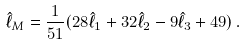Convert formula to latex. <formula><loc_0><loc_0><loc_500><loc_500>\hat { \ell } _ { M } = \frac { 1 } { 5 1 } ( 2 8 \hat { \ell } _ { 1 } + 3 2 \hat { \ell } _ { 2 } - 9 \hat { \ell } _ { 3 } + 4 9 ) \, .</formula> 